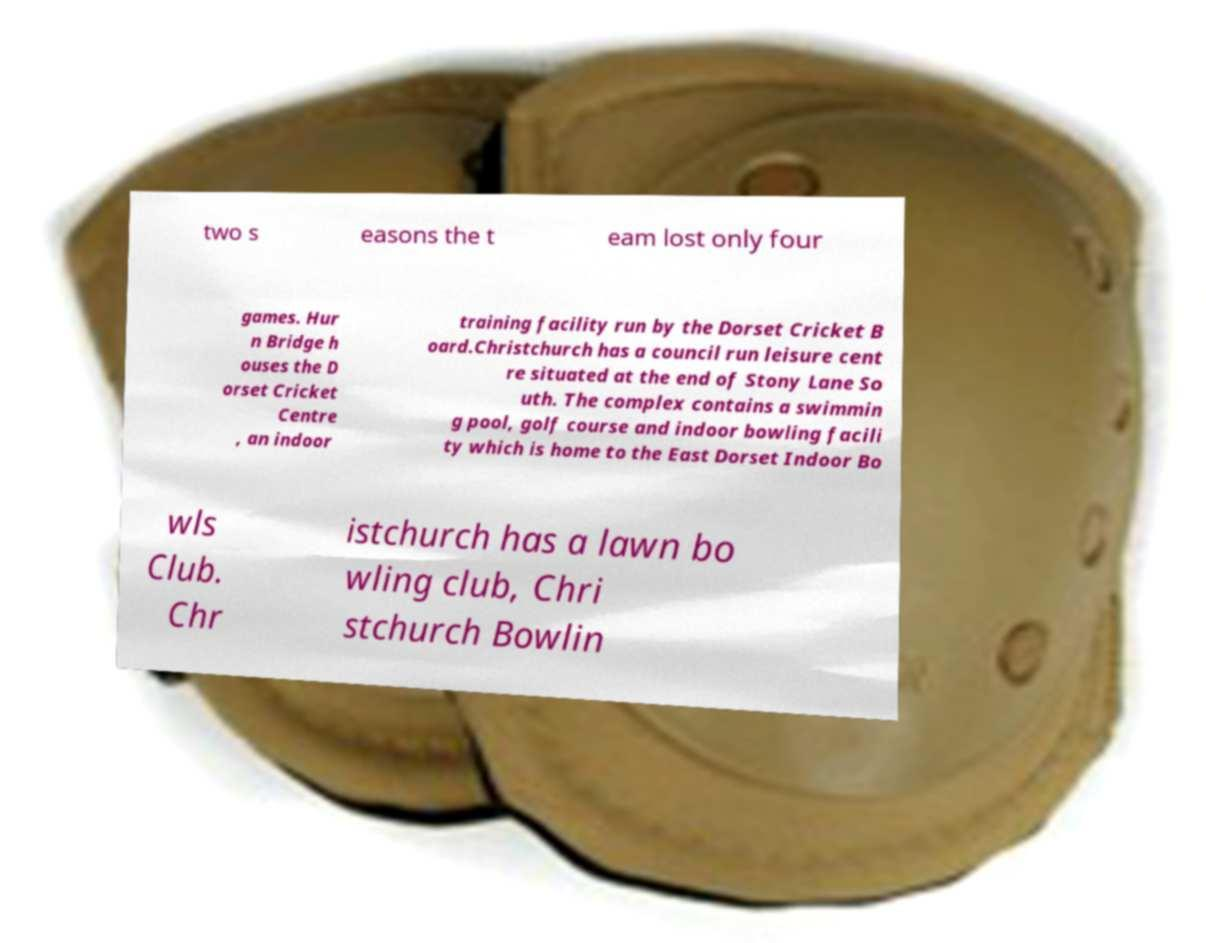Could you assist in decoding the text presented in this image and type it out clearly? two s easons the t eam lost only four games. Hur n Bridge h ouses the D orset Cricket Centre , an indoor training facility run by the Dorset Cricket B oard.Christchurch has a council run leisure cent re situated at the end of Stony Lane So uth. The complex contains a swimmin g pool, golf course and indoor bowling facili ty which is home to the East Dorset Indoor Bo wls Club. Chr istchurch has a lawn bo wling club, Chri stchurch Bowlin 